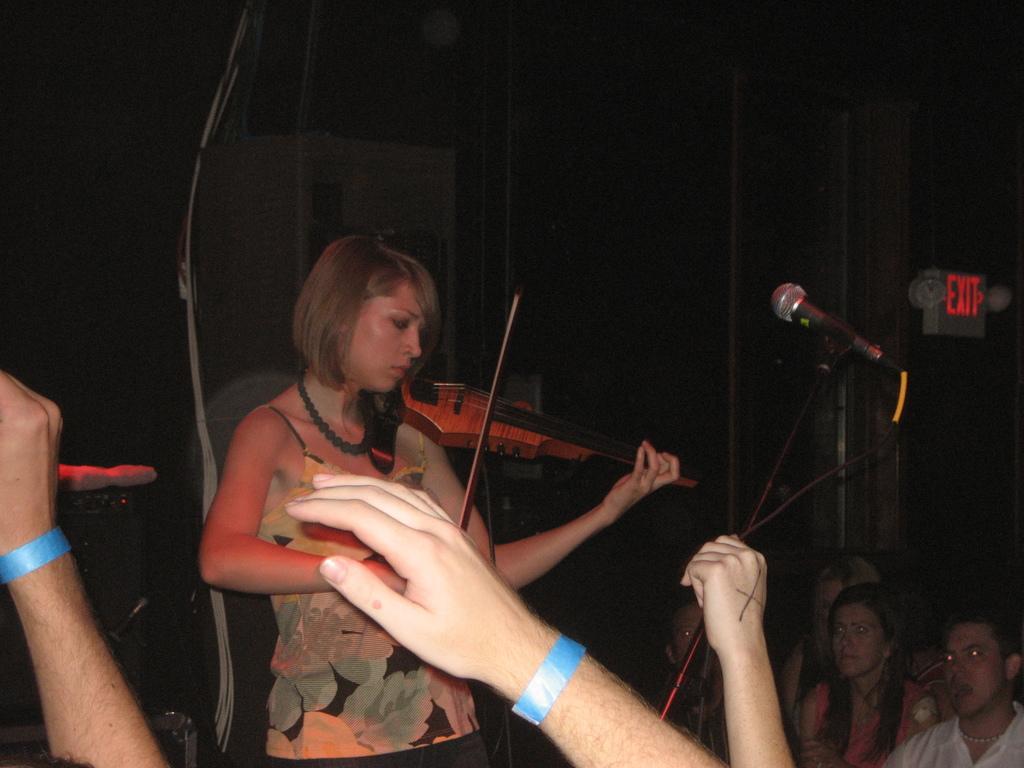Please provide a concise description of this image. In this image there are group of people. There is a women standing in the middle and she is playing musical instrument. At the front there is a microphone, at the back there is a door, at the bottom there are group of people. 